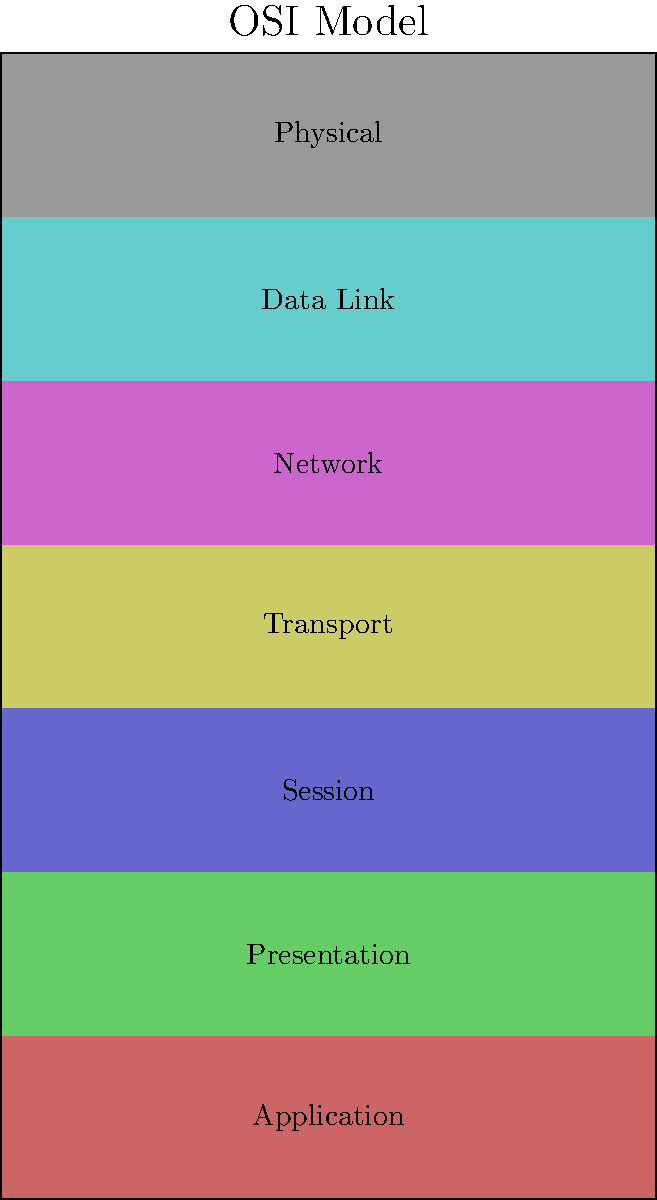In the OSI model shown above, which layer is responsible for routing and forwarding data packets between different networks? To answer this question, let's break down the OSI (Open Systems Interconnection) model layers and their functions:

1. Physical Layer: Deals with the physical transmission of data bits.
2. Data Link Layer: Handles error-free transfer of data frames between two nodes.
3. Network Layer: Responsible for routing and forwarding data packets between different networks.
4. Transport Layer: Ensures end-to-end communication and data flow control.
5. Session Layer: Manages and terminates connections between applications.
6. Presentation Layer: Formats and encrypts data for the application layer.
7. Application Layer: Provides network services directly to end-users or applications.

The layer responsible for routing and forwarding data packets between different networks is the Network Layer. This layer uses logical addressing (such as IP addresses) to determine the best path for data to travel from the source to the destination, even if they are on different networks.
Answer: Network Layer 